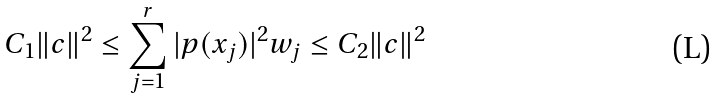<formula> <loc_0><loc_0><loc_500><loc_500>C _ { 1 } \| c \| ^ { 2 } \leq \sum _ { j = 1 } ^ { r } | p ( x _ { j } ) | ^ { 2 } w _ { j } \leq C _ { 2 } \| c \| ^ { 2 }</formula> 